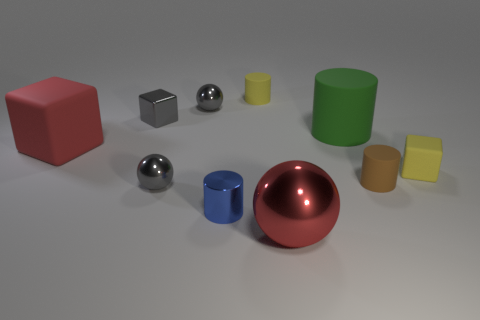Is there anything else that has the same shape as the large green thing?
Keep it short and to the point. Yes. What number of cylinders are big red objects or small gray metallic things?
Provide a short and direct response. 0. The small brown matte thing has what shape?
Keep it short and to the point. Cylinder. Are there any tiny brown things right of the small brown matte cylinder?
Your answer should be compact. No. Is the green object made of the same material as the small cube that is in front of the large green object?
Your answer should be very brief. Yes. There is a red object behind the small blue metallic thing; is its shape the same as the blue thing?
Offer a very short reply. No. How many cubes have the same material as the small yellow cylinder?
Keep it short and to the point. 2. How many things are either gray spheres that are to the left of the small blue cylinder or purple matte objects?
Your response must be concise. 2. How big is the red metal ball?
Keep it short and to the point. Large. What material is the tiny gray thing in front of the small rubber cylinder that is right of the green matte cylinder?
Your answer should be very brief. Metal. 